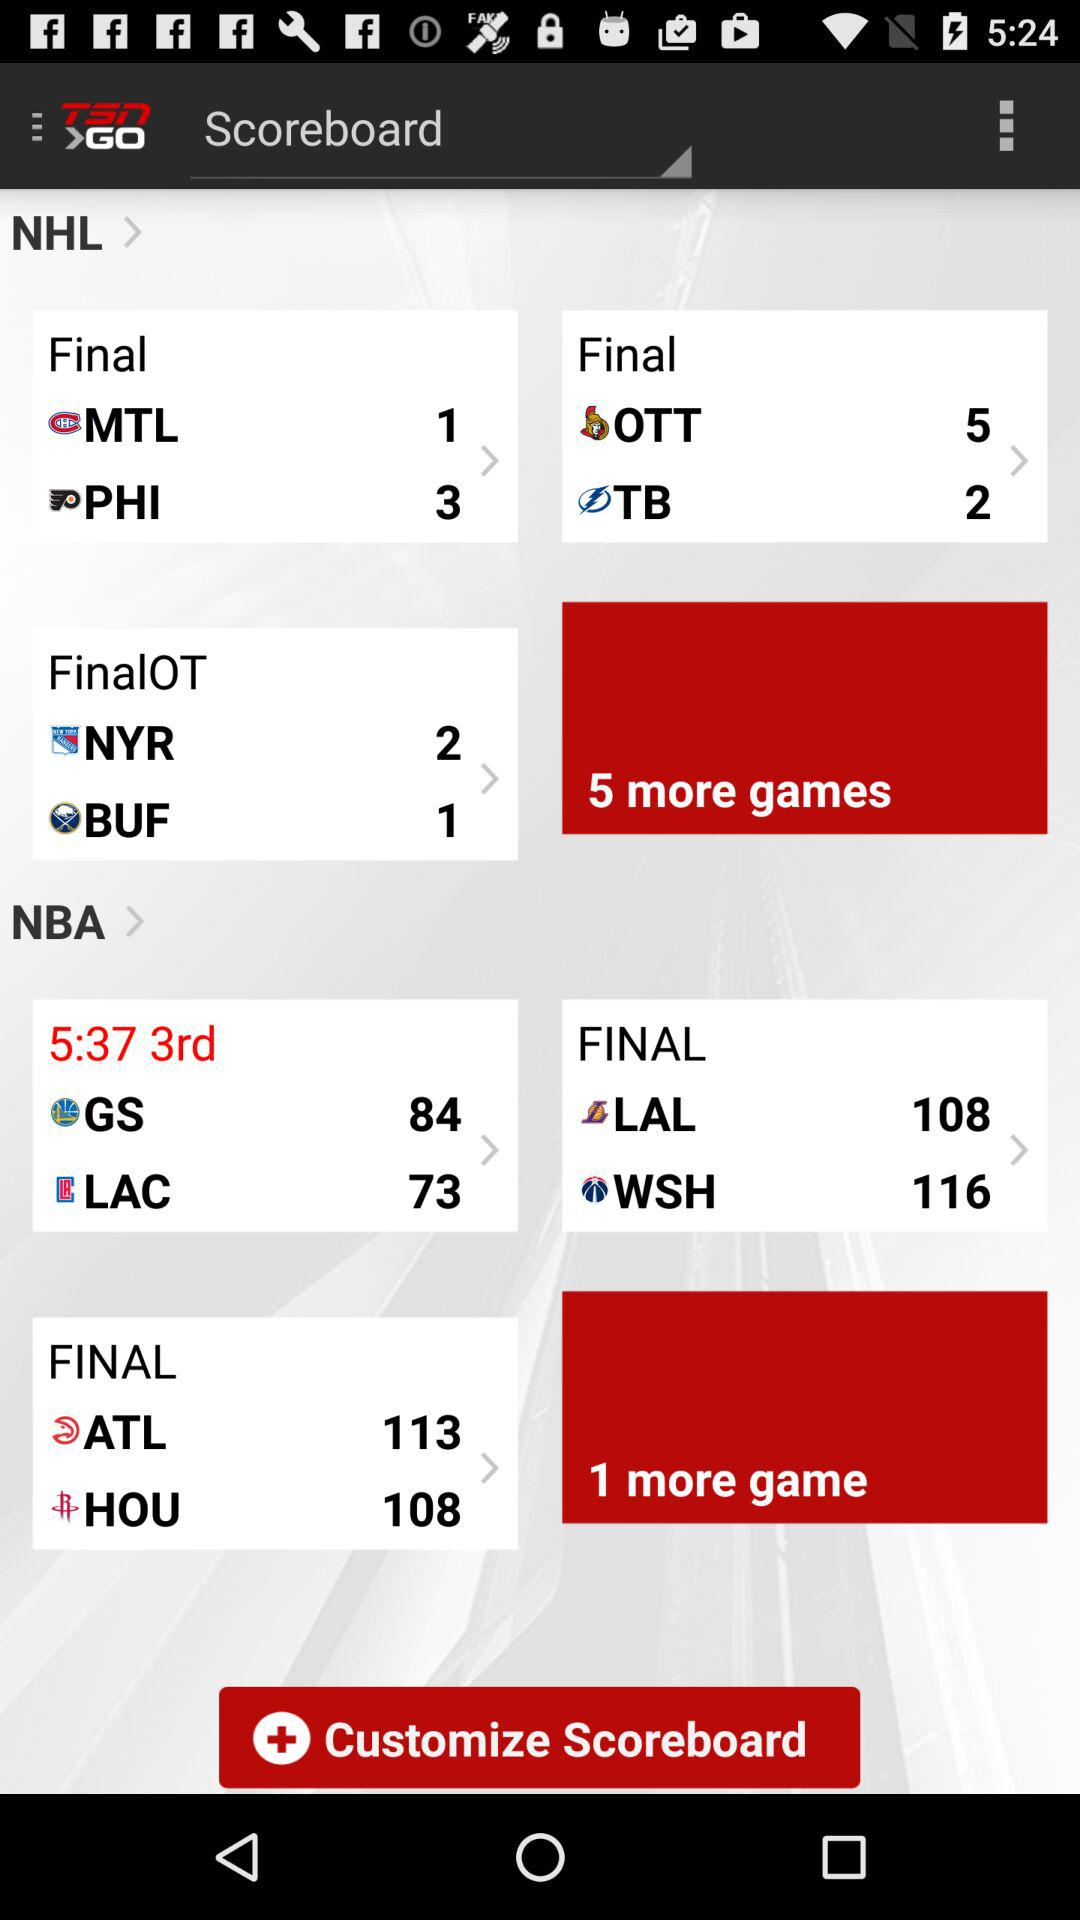How many more games are there in the NHL scoreboard? There are 5 more games in the NHL scoreboard. 